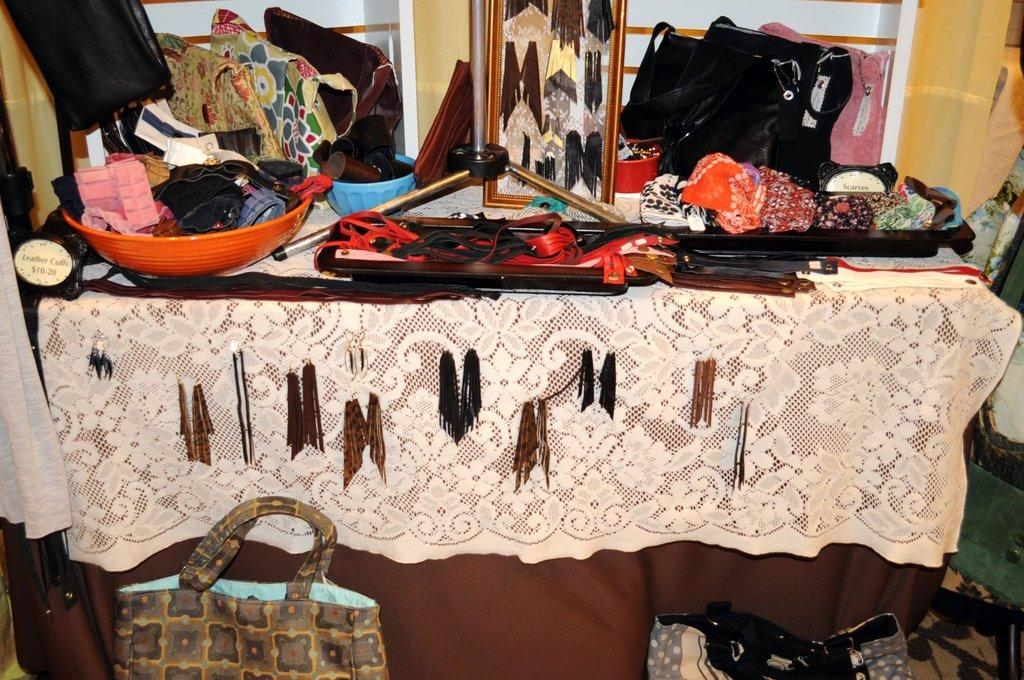What objects are placed on the table in the image? There are bags placed on a table in the image. How is the table decorated or covered? The table is covered with a curtain. Can you identify any other objects in the image besides the bags? Yes, there is a plastic bowl in the image. What type of medical advice can be sought from the doctor in the image? There is no doctor present in the image, so medical advice cannot be sought. 